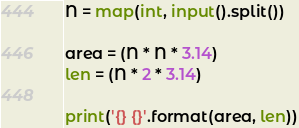<code> <loc_0><loc_0><loc_500><loc_500><_Python_>N = map(int, input().split())

area = (N * N * 3.14)
len = (N * 2 * 3.14)

print('{} {}'.format(area, len))</code> 